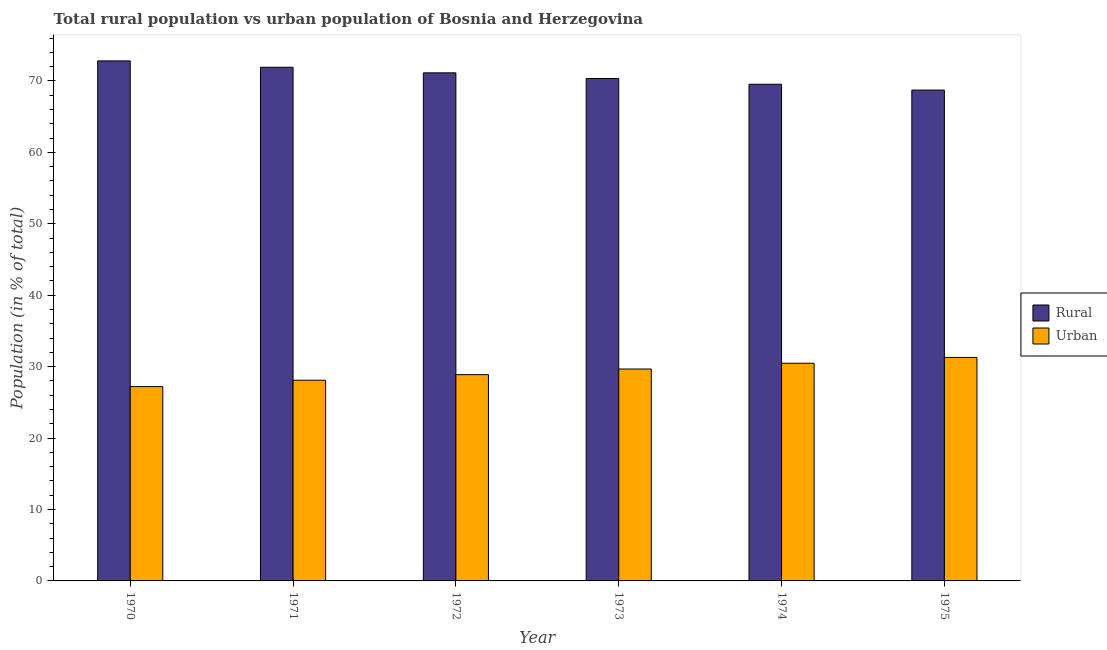How many groups of bars are there?
Your answer should be very brief. 6. Are the number of bars on each tick of the X-axis equal?
Make the answer very short. Yes. How many bars are there on the 6th tick from the right?
Offer a terse response. 2. What is the label of the 6th group of bars from the left?
Provide a succinct answer. 1975. What is the urban population in 1970?
Provide a short and direct response. 27.2. Across all years, what is the maximum urban population?
Make the answer very short. 31.29. Across all years, what is the minimum rural population?
Offer a terse response. 68.71. In which year was the rural population minimum?
Your answer should be very brief. 1975. What is the total rural population in the graph?
Offer a terse response. 424.4. What is the difference between the rural population in 1971 and that in 1973?
Your response must be concise. 1.57. What is the difference between the urban population in 1971 and the rural population in 1970?
Keep it short and to the point. 0.89. What is the average rural population per year?
Give a very brief answer. 70.73. In the year 1970, what is the difference between the rural population and urban population?
Your answer should be very brief. 0. In how many years, is the rural population greater than 12 %?
Provide a short and direct response. 6. What is the ratio of the rural population in 1972 to that in 1974?
Keep it short and to the point. 1.02. Is the urban population in 1970 less than that in 1975?
Provide a succinct answer. Yes. Is the difference between the urban population in 1970 and 1971 greater than the difference between the rural population in 1970 and 1971?
Make the answer very short. No. What is the difference between the highest and the second highest rural population?
Keep it short and to the point. 0.89. What is the difference between the highest and the lowest rural population?
Your answer should be very brief. 4.09. In how many years, is the urban population greater than the average urban population taken over all years?
Offer a very short reply. 3. What does the 2nd bar from the left in 1974 represents?
Make the answer very short. Urban. What does the 1st bar from the right in 1970 represents?
Offer a very short reply. Urban. How many years are there in the graph?
Keep it short and to the point. 6. What is the difference between two consecutive major ticks on the Y-axis?
Ensure brevity in your answer.  10. How many legend labels are there?
Provide a short and direct response. 2. How are the legend labels stacked?
Provide a succinct answer. Vertical. What is the title of the graph?
Give a very brief answer. Total rural population vs urban population of Bosnia and Herzegovina. What is the label or title of the X-axis?
Provide a short and direct response. Year. What is the label or title of the Y-axis?
Your answer should be very brief. Population (in % of total). What is the Population (in % of total) of Rural in 1970?
Make the answer very short. 72.8. What is the Population (in % of total) in Urban in 1970?
Offer a terse response. 27.2. What is the Population (in % of total) of Rural in 1971?
Your answer should be compact. 71.91. What is the Population (in % of total) of Urban in 1971?
Give a very brief answer. 28.09. What is the Population (in % of total) of Rural in 1972?
Ensure brevity in your answer.  71.12. What is the Population (in % of total) of Urban in 1972?
Your answer should be very brief. 28.88. What is the Population (in % of total) of Rural in 1973?
Offer a terse response. 70.33. What is the Population (in % of total) in Urban in 1973?
Keep it short and to the point. 29.67. What is the Population (in % of total) of Rural in 1974?
Your answer should be compact. 69.53. What is the Population (in % of total) in Urban in 1974?
Keep it short and to the point. 30.47. What is the Population (in % of total) in Rural in 1975?
Provide a short and direct response. 68.71. What is the Population (in % of total) in Urban in 1975?
Provide a succinct answer. 31.29. Across all years, what is the maximum Population (in % of total) of Rural?
Your answer should be very brief. 72.8. Across all years, what is the maximum Population (in % of total) of Urban?
Provide a succinct answer. 31.29. Across all years, what is the minimum Population (in % of total) of Rural?
Make the answer very short. 68.71. Across all years, what is the minimum Population (in % of total) of Urban?
Your response must be concise. 27.2. What is the total Population (in % of total) of Rural in the graph?
Make the answer very short. 424.4. What is the total Population (in % of total) of Urban in the graph?
Give a very brief answer. 175.59. What is the difference between the Population (in % of total) of Rural in 1970 and that in 1971?
Give a very brief answer. 0.89. What is the difference between the Population (in % of total) of Urban in 1970 and that in 1971?
Keep it short and to the point. -0.89. What is the difference between the Population (in % of total) in Rural in 1970 and that in 1972?
Provide a short and direct response. 1.67. What is the difference between the Population (in % of total) of Urban in 1970 and that in 1972?
Offer a very short reply. -1.67. What is the difference between the Population (in % of total) in Rural in 1970 and that in 1973?
Make the answer very short. 2.46. What is the difference between the Population (in % of total) in Urban in 1970 and that in 1973?
Provide a succinct answer. -2.46. What is the difference between the Population (in % of total) of Rural in 1970 and that in 1974?
Ensure brevity in your answer.  3.27. What is the difference between the Population (in % of total) in Urban in 1970 and that in 1974?
Offer a very short reply. -3.27. What is the difference between the Population (in % of total) in Rural in 1970 and that in 1975?
Keep it short and to the point. 4.09. What is the difference between the Population (in % of total) of Urban in 1970 and that in 1975?
Offer a terse response. -4.09. What is the difference between the Population (in % of total) of Rural in 1971 and that in 1972?
Make the answer very short. 0.78. What is the difference between the Population (in % of total) of Urban in 1971 and that in 1972?
Ensure brevity in your answer.  -0.78. What is the difference between the Population (in % of total) in Rural in 1971 and that in 1973?
Keep it short and to the point. 1.57. What is the difference between the Population (in % of total) in Urban in 1971 and that in 1973?
Provide a succinct answer. -1.57. What is the difference between the Population (in % of total) of Rural in 1971 and that in 1974?
Keep it short and to the point. 2.38. What is the difference between the Population (in % of total) in Urban in 1971 and that in 1974?
Your response must be concise. -2.38. What is the difference between the Population (in % of total) of Rural in 1971 and that in 1975?
Your response must be concise. 3.19. What is the difference between the Population (in % of total) of Urban in 1971 and that in 1975?
Offer a very short reply. -3.19. What is the difference between the Population (in % of total) of Rural in 1972 and that in 1973?
Keep it short and to the point. 0.79. What is the difference between the Population (in % of total) of Urban in 1972 and that in 1973?
Your answer should be very brief. -0.79. What is the difference between the Population (in % of total) of Rural in 1972 and that in 1974?
Your response must be concise. 1.6. What is the difference between the Population (in % of total) of Urban in 1972 and that in 1974?
Provide a short and direct response. -1.6. What is the difference between the Population (in % of total) of Rural in 1972 and that in 1975?
Your answer should be compact. 2.41. What is the difference between the Population (in % of total) of Urban in 1972 and that in 1975?
Your response must be concise. -2.41. What is the difference between the Population (in % of total) of Rural in 1973 and that in 1974?
Your answer should be compact. 0.81. What is the difference between the Population (in % of total) in Urban in 1973 and that in 1974?
Provide a succinct answer. -0.81. What is the difference between the Population (in % of total) in Rural in 1973 and that in 1975?
Your answer should be very brief. 1.62. What is the difference between the Population (in % of total) of Urban in 1973 and that in 1975?
Make the answer very short. -1.62. What is the difference between the Population (in % of total) in Rural in 1974 and that in 1975?
Your response must be concise. 0.82. What is the difference between the Population (in % of total) in Urban in 1974 and that in 1975?
Offer a terse response. -0.82. What is the difference between the Population (in % of total) of Rural in 1970 and the Population (in % of total) of Urban in 1971?
Your answer should be very brief. 44.7. What is the difference between the Population (in % of total) of Rural in 1970 and the Population (in % of total) of Urban in 1972?
Make the answer very short. 43.92. What is the difference between the Population (in % of total) in Rural in 1970 and the Population (in % of total) in Urban in 1973?
Keep it short and to the point. 43.13. What is the difference between the Population (in % of total) in Rural in 1970 and the Population (in % of total) in Urban in 1974?
Provide a short and direct response. 42.33. What is the difference between the Population (in % of total) in Rural in 1970 and the Population (in % of total) in Urban in 1975?
Offer a terse response. 41.51. What is the difference between the Population (in % of total) in Rural in 1971 and the Population (in % of total) in Urban in 1972?
Ensure brevity in your answer.  43.03. What is the difference between the Population (in % of total) of Rural in 1971 and the Population (in % of total) of Urban in 1973?
Provide a short and direct response. 42.24. What is the difference between the Population (in % of total) in Rural in 1971 and the Population (in % of total) in Urban in 1974?
Ensure brevity in your answer.  41.44. What is the difference between the Population (in % of total) of Rural in 1971 and the Population (in % of total) of Urban in 1975?
Your response must be concise. 40.62. What is the difference between the Population (in % of total) of Rural in 1972 and the Population (in % of total) of Urban in 1973?
Your answer should be compact. 41.46. What is the difference between the Population (in % of total) of Rural in 1972 and the Population (in % of total) of Urban in 1974?
Ensure brevity in your answer.  40.65. What is the difference between the Population (in % of total) of Rural in 1972 and the Population (in % of total) of Urban in 1975?
Offer a very short reply. 39.84. What is the difference between the Population (in % of total) in Rural in 1973 and the Population (in % of total) in Urban in 1974?
Ensure brevity in your answer.  39.86. What is the difference between the Population (in % of total) in Rural in 1973 and the Population (in % of total) in Urban in 1975?
Make the answer very short. 39.05. What is the difference between the Population (in % of total) of Rural in 1974 and the Population (in % of total) of Urban in 1975?
Your answer should be compact. 38.24. What is the average Population (in % of total) of Rural per year?
Provide a short and direct response. 70.73. What is the average Population (in % of total) of Urban per year?
Offer a very short reply. 29.27. In the year 1970, what is the difference between the Population (in % of total) in Rural and Population (in % of total) in Urban?
Provide a short and direct response. 45.6. In the year 1971, what is the difference between the Population (in % of total) in Rural and Population (in % of total) in Urban?
Provide a succinct answer. 43.81. In the year 1972, what is the difference between the Population (in % of total) of Rural and Population (in % of total) of Urban?
Provide a short and direct response. 42.25. In the year 1973, what is the difference between the Population (in % of total) of Rural and Population (in % of total) of Urban?
Provide a succinct answer. 40.67. In the year 1974, what is the difference between the Population (in % of total) in Rural and Population (in % of total) in Urban?
Your response must be concise. 39.06. In the year 1975, what is the difference between the Population (in % of total) in Rural and Population (in % of total) in Urban?
Make the answer very short. 37.42. What is the ratio of the Population (in % of total) in Rural in 1970 to that in 1971?
Offer a terse response. 1.01. What is the ratio of the Population (in % of total) in Urban in 1970 to that in 1971?
Your answer should be compact. 0.97. What is the ratio of the Population (in % of total) of Rural in 1970 to that in 1972?
Keep it short and to the point. 1.02. What is the ratio of the Population (in % of total) of Urban in 1970 to that in 1972?
Provide a short and direct response. 0.94. What is the ratio of the Population (in % of total) of Rural in 1970 to that in 1973?
Give a very brief answer. 1.03. What is the ratio of the Population (in % of total) in Urban in 1970 to that in 1973?
Your answer should be very brief. 0.92. What is the ratio of the Population (in % of total) in Rural in 1970 to that in 1974?
Your answer should be compact. 1.05. What is the ratio of the Population (in % of total) in Urban in 1970 to that in 1974?
Offer a very short reply. 0.89. What is the ratio of the Population (in % of total) in Rural in 1970 to that in 1975?
Make the answer very short. 1.06. What is the ratio of the Population (in % of total) of Urban in 1970 to that in 1975?
Provide a short and direct response. 0.87. What is the ratio of the Population (in % of total) in Urban in 1971 to that in 1972?
Keep it short and to the point. 0.97. What is the ratio of the Population (in % of total) in Rural in 1971 to that in 1973?
Provide a short and direct response. 1.02. What is the ratio of the Population (in % of total) in Urban in 1971 to that in 1973?
Your answer should be very brief. 0.95. What is the ratio of the Population (in % of total) of Rural in 1971 to that in 1974?
Provide a succinct answer. 1.03. What is the ratio of the Population (in % of total) in Urban in 1971 to that in 1974?
Offer a terse response. 0.92. What is the ratio of the Population (in % of total) of Rural in 1971 to that in 1975?
Offer a terse response. 1.05. What is the ratio of the Population (in % of total) in Urban in 1971 to that in 1975?
Your answer should be very brief. 0.9. What is the ratio of the Population (in % of total) of Rural in 1972 to that in 1973?
Provide a succinct answer. 1.01. What is the ratio of the Population (in % of total) of Urban in 1972 to that in 1973?
Provide a succinct answer. 0.97. What is the ratio of the Population (in % of total) in Urban in 1972 to that in 1974?
Offer a terse response. 0.95. What is the ratio of the Population (in % of total) in Rural in 1972 to that in 1975?
Make the answer very short. 1.04. What is the ratio of the Population (in % of total) of Urban in 1972 to that in 1975?
Provide a succinct answer. 0.92. What is the ratio of the Population (in % of total) in Rural in 1973 to that in 1974?
Your response must be concise. 1.01. What is the ratio of the Population (in % of total) of Urban in 1973 to that in 1974?
Offer a very short reply. 0.97. What is the ratio of the Population (in % of total) of Rural in 1973 to that in 1975?
Give a very brief answer. 1.02. What is the ratio of the Population (in % of total) of Urban in 1973 to that in 1975?
Your answer should be very brief. 0.95. What is the ratio of the Population (in % of total) of Rural in 1974 to that in 1975?
Give a very brief answer. 1.01. What is the ratio of the Population (in % of total) in Urban in 1974 to that in 1975?
Ensure brevity in your answer.  0.97. What is the difference between the highest and the second highest Population (in % of total) in Rural?
Make the answer very short. 0.89. What is the difference between the highest and the second highest Population (in % of total) of Urban?
Offer a terse response. 0.82. What is the difference between the highest and the lowest Population (in % of total) in Rural?
Provide a short and direct response. 4.09. What is the difference between the highest and the lowest Population (in % of total) in Urban?
Ensure brevity in your answer.  4.09. 